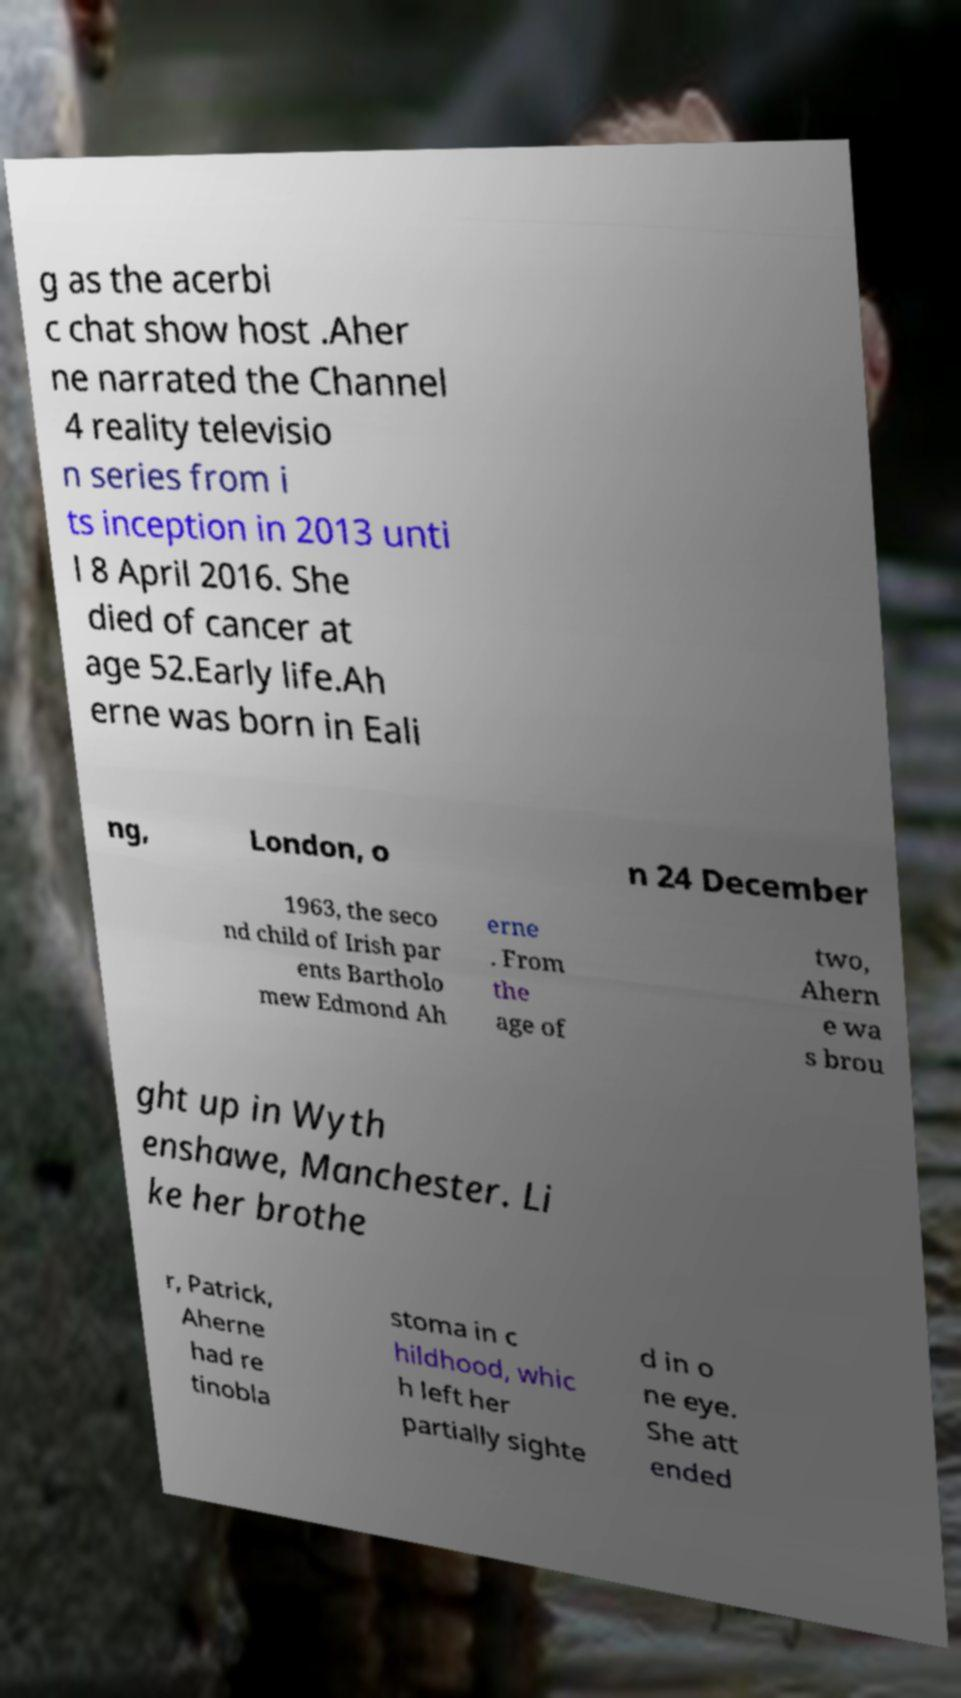Can you accurately transcribe the text from the provided image for me? g as the acerbi c chat show host .Aher ne narrated the Channel 4 reality televisio n series from i ts inception in 2013 unti l 8 April 2016. She died of cancer at age 52.Early life.Ah erne was born in Eali ng, London, o n 24 December 1963, the seco nd child of Irish par ents Bartholo mew Edmond Ah erne . From the age of two, Ahern e wa s brou ght up in Wyth enshawe, Manchester. Li ke her brothe r, Patrick, Aherne had re tinobla stoma in c hildhood, whic h left her partially sighte d in o ne eye. She att ended 